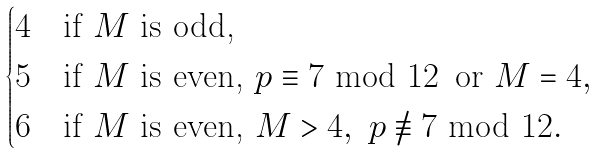Convert formula to latex. <formula><loc_0><loc_0><loc_500><loc_500>\begin{cases} 4 & \text {if $M$ is odd,} \\ 5 & \text {if $M$ is even, } p \equiv 7 \text { mod } 1 2 \, \text { or } M = 4 , \\ 6 & \text {if $M$ is even, } M > 4 , \ p \not \equiv 7 \text { mod } 1 2 . \end{cases}</formula> 